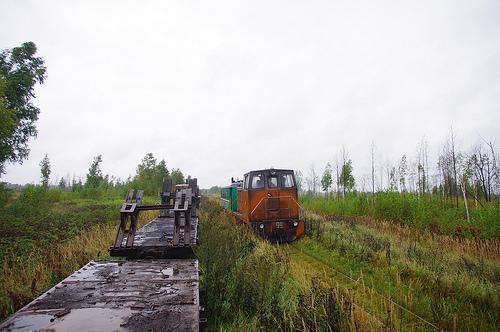How many trains on the train tracks?
Give a very brief answer. 1. 